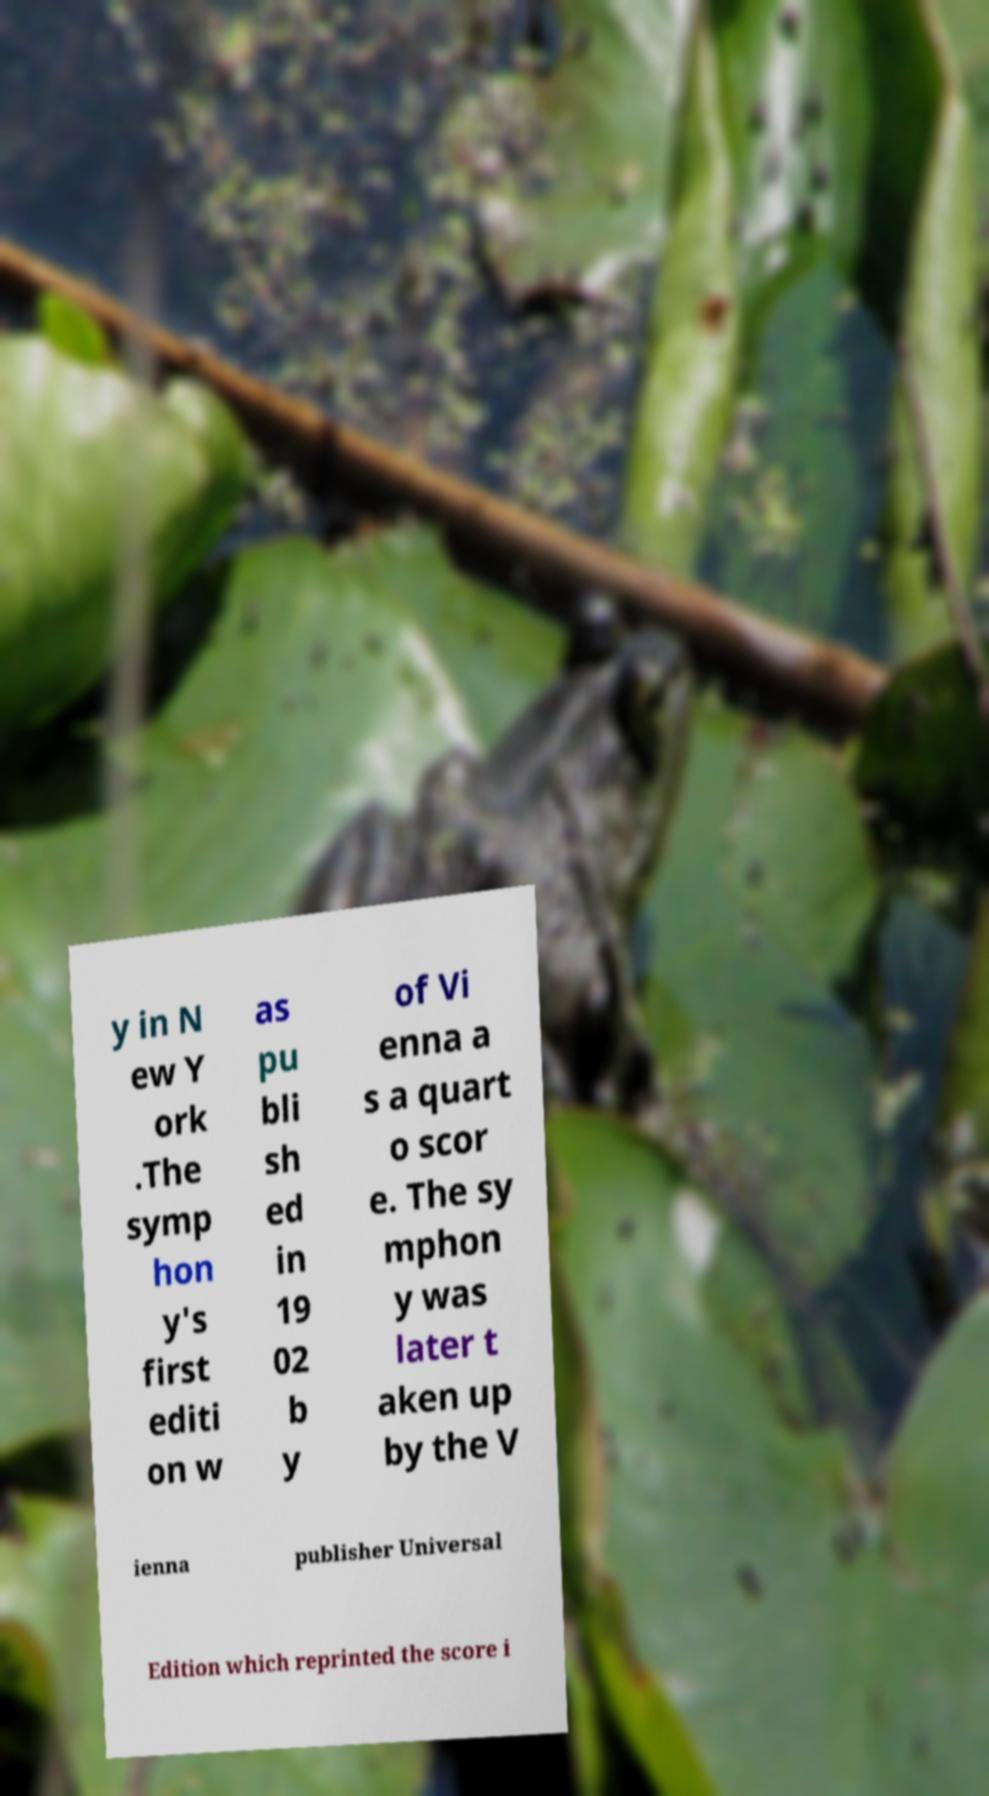Please identify and transcribe the text found in this image. y in N ew Y ork .The symp hon y's first editi on w as pu bli sh ed in 19 02 b y of Vi enna a s a quart o scor e. The sy mphon y was later t aken up by the V ienna publisher Universal Edition which reprinted the score i 